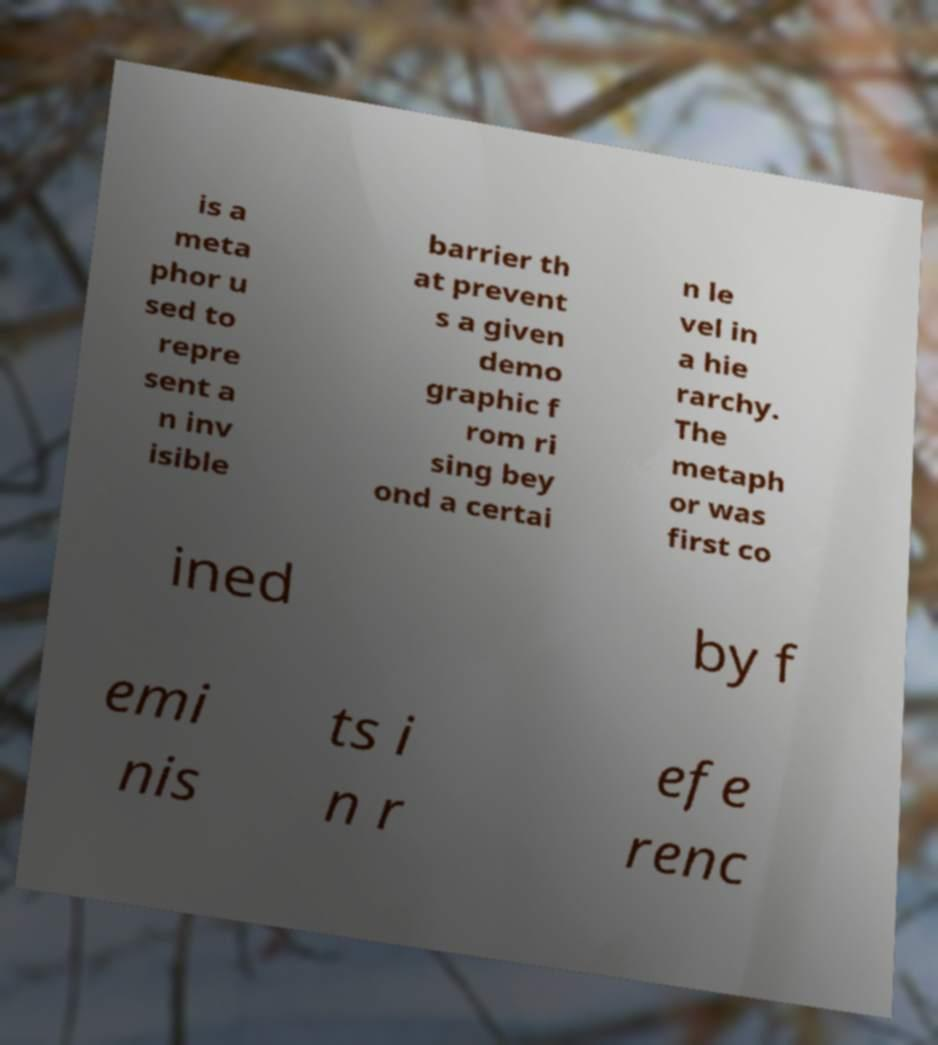Could you assist in decoding the text presented in this image and type it out clearly? is a meta phor u sed to repre sent a n inv isible barrier th at prevent s a given demo graphic f rom ri sing bey ond a certai n le vel in a hie rarchy. The metaph or was first co ined by f emi nis ts i n r efe renc 